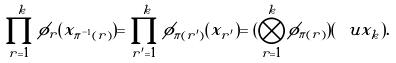<formula> <loc_0><loc_0><loc_500><loc_500>\prod _ { r = 1 } ^ { k } \phi _ { r } ( x _ { \pi ^ { - 1 } ( r ) } ) = \prod _ { r ^ { \prime } = 1 } ^ { k } \phi _ { \pi ( r ^ { \prime } ) } ( x _ { r ^ { \prime } } ) = ( \bigotimes _ { r = 1 } ^ { k } \phi _ { \pi ( r ) } ) ( \ u x _ { k } ) .</formula> 